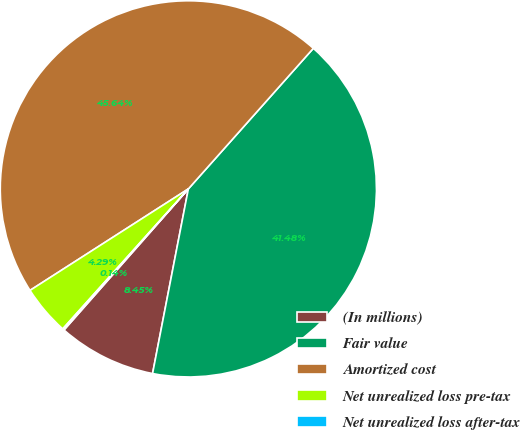Convert chart. <chart><loc_0><loc_0><loc_500><loc_500><pie_chart><fcel>(In millions)<fcel>Fair value<fcel>Amortized cost<fcel>Net unrealized loss pre-tax<fcel>Net unrealized loss after-tax<nl><fcel>8.45%<fcel>41.48%<fcel>45.64%<fcel>4.29%<fcel>0.14%<nl></chart> 